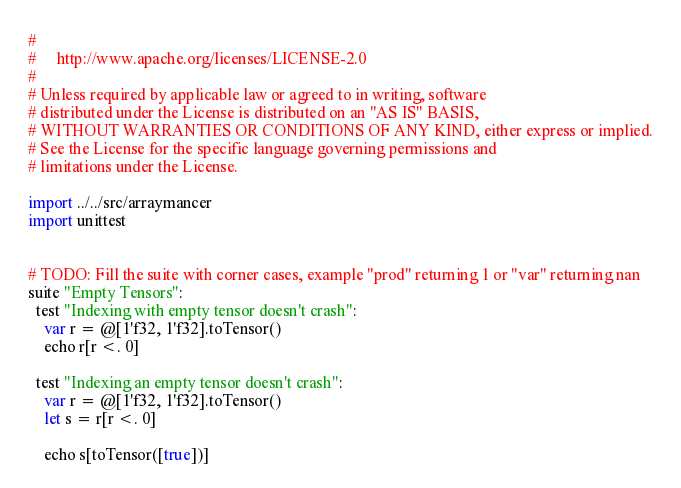<code> <loc_0><loc_0><loc_500><loc_500><_Nim_>#
#     http://www.apache.org/licenses/LICENSE-2.0
#
# Unless required by applicable law or agreed to in writing, software
# distributed under the License is distributed on an "AS IS" BASIS,
# WITHOUT WARRANTIES OR CONDITIONS OF ANY KIND, either express or implied.
# See the License for the specific language governing permissions and
# limitations under the License.

import ../../src/arraymancer
import unittest


# TODO: Fill the suite with corner cases, example "prod" returning 1 or "var" returning nan
suite "Empty Tensors":
  test "Indexing with empty tensor doesn't crash":
    var r = @[1'f32, 1'f32].toTensor()
    echo r[r <. 0]

  test "Indexing an empty tensor doesn't crash":
    var r = @[1'f32, 1'f32].toTensor()
    let s = r[r <. 0]

    echo s[toTensor([true])]
</code> 